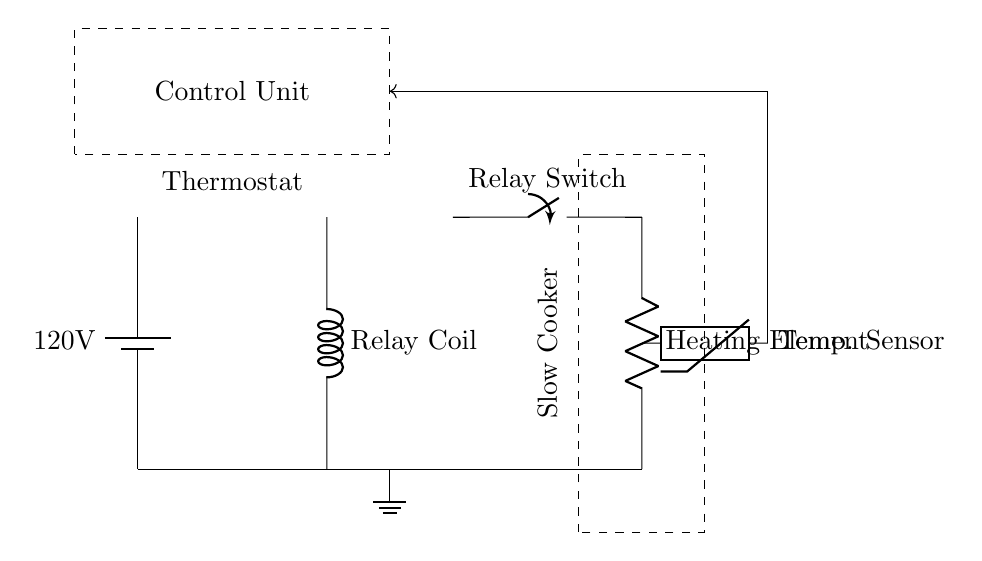What is the voltage of the power supply? The power supply in the circuit is specified as 120V, which is indicated next to the battery symbol.
Answer: 120V What is the purpose of the relay in this circuit? The relay is used to control the switching of the heating element based on signals from the thermostat. The relay coil is energized by the thermostat, which in turn closes the switch to the heating element.
Answer: Control switching What type of sensor is used in this circuit? The temperature sensor depicted is a thermistor, which is marked in the diagram and is commonly used for measuring temperature changes.
Answer: Thermistor How does the thermostat influence the circuit operation? The thermostat monitors the temperature and provides feedback to the control unit. When the temperature reaches a specified level, it activates the relay coil which then operates the relay switch to control the heating element.
Answer: Regulates temperature What connects the temperature sensor to the control unit? There is a feedback line indicated by an arrow that connects the temperature sensor to the control unit. This line shows the path through which temperature information is relayed.
Answer: Feedback line What component keeps the heating element turned on? The relay switch is responsible for keeping the heating element turned on when the relay coil is energized by the thermostat, allowing current to flow to the heating element.
Answer: Relay switch 